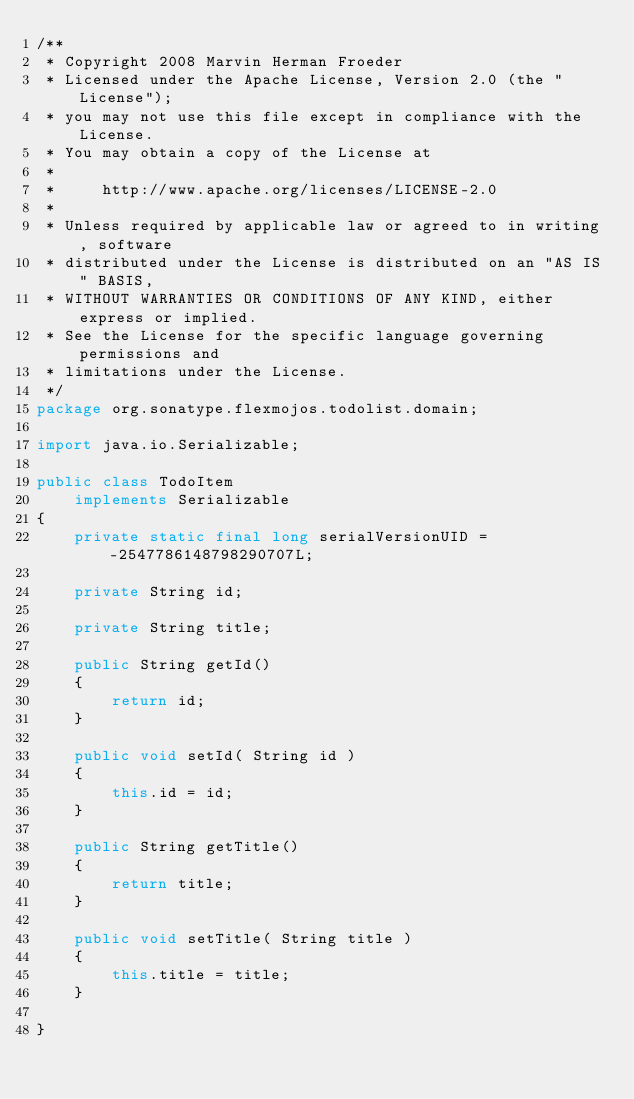Convert code to text. <code><loc_0><loc_0><loc_500><loc_500><_Java_>/**
 * Copyright 2008 Marvin Herman Froeder
 * Licensed under the Apache License, Version 2.0 (the "License");
 * you may not use this file except in compliance with the License.
 * You may obtain a copy of the License at
 *
 *     http://www.apache.org/licenses/LICENSE-2.0
 *
 * Unless required by applicable law or agreed to in writing, software
 * distributed under the License is distributed on an "AS IS" BASIS,
 * WITHOUT WARRANTIES OR CONDITIONS OF ANY KIND, either express or implied.
 * See the License for the specific language governing permissions and
 * limitations under the License.
 */
package org.sonatype.flexmojos.todolist.domain;

import java.io.Serializable;

public class TodoItem
    implements Serializable
{
    private static final long serialVersionUID = -2547786148798290707L;

    private String id;

    private String title;

    public String getId()
    {
        return id;
    }

    public void setId( String id )
    {
        this.id = id;
    }

    public String getTitle()
    {
        return title;
    }

    public void setTitle( String title )
    {
        this.title = title;
    }

}
</code> 